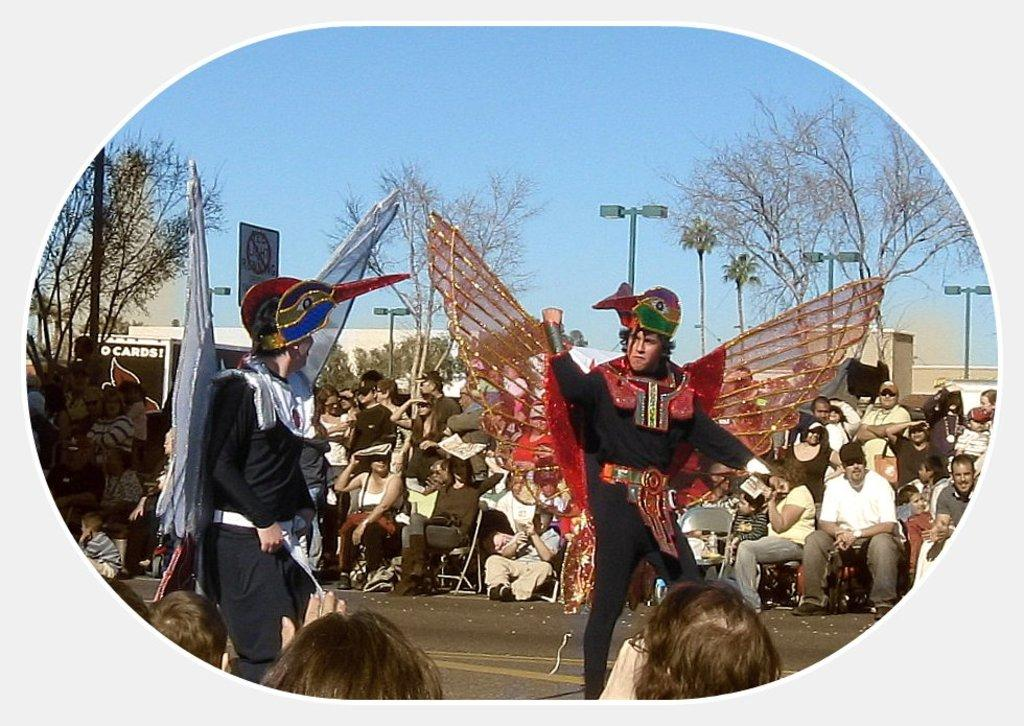What are the people in the image doing? There is a group of people sitting on chairs in the image. Are there any other people in the image besides those sitting? Yes, two persons are standing in the image. What are the standing persons wearing? The standing persons are wearing costumes. What can be seen in the background of the image? There are trees and the sky visible in the background of the image. What type of garden can be seen in the image? There is no garden present in the image. What musical instrument is being played by the standing persons? The standing persons are not playing any musical instrument in the image. 